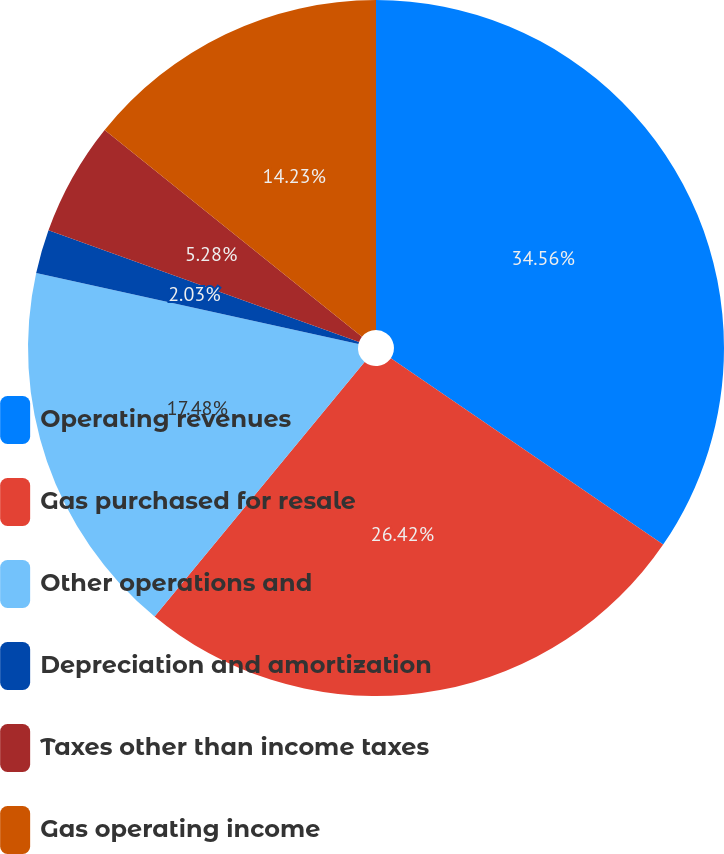Convert chart to OTSL. <chart><loc_0><loc_0><loc_500><loc_500><pie_chart><fcel>Operating revenues<fcel>Gas purchased for resale<fcel>Other operations and<fcel>Depreciation and amortization<fcel>Taxes other than income taxes<fcel>Gas operating income<nl><fcel>34.55%<fcel>26.42%<fcel>17.48%<fcel>2.03%<fcel>5.28%<fcel>14.23%<nl></chart> 